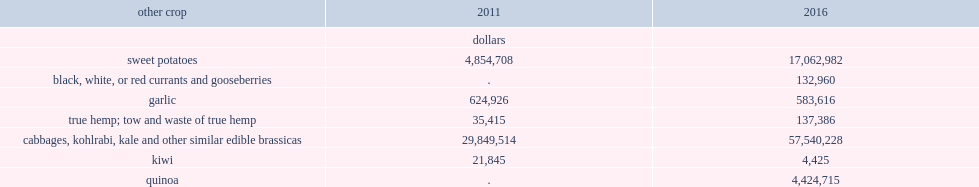How many times did export totals for sweet potatoes increase from 2011 to 2016? 3.514729. What is the grow rate of kale and other similar edible brassicas export from 2011 to 2016? 0.927677. How much did garlic export totals decline from 2011 to 2016? 41310. Which sectors of crop export totals increased from 2011 to 2016? Sweet potatoes true hemp; tow and waste of true hemp cabbages, kohlrabi, kale and other similar edible brassicas. Which sectors of crop export totals decreased from 2011 to 2016? Garlic kiwi. 